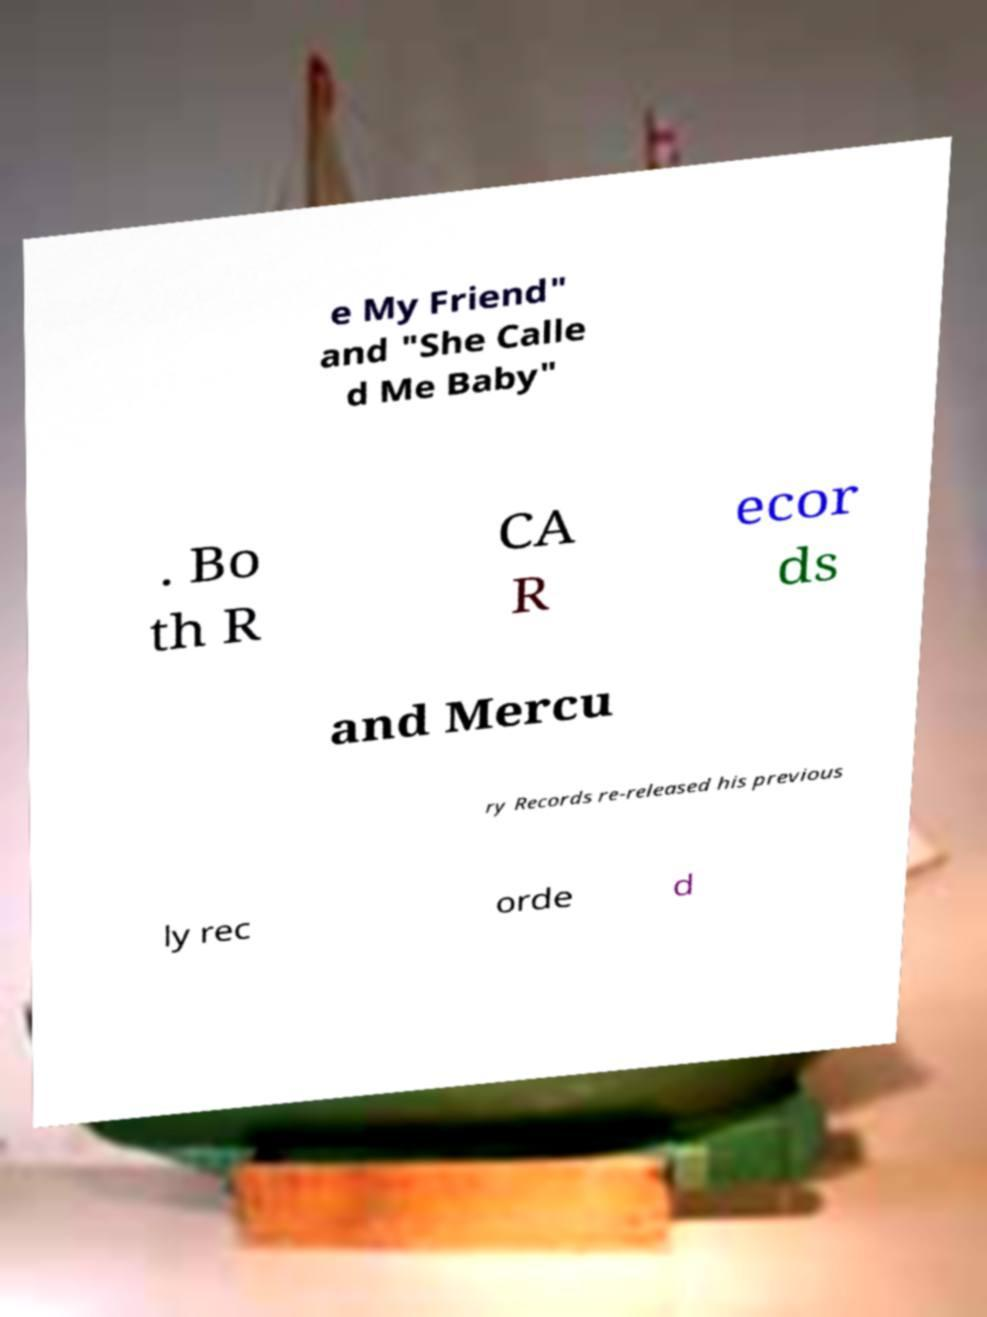Can you accurately transcribe the text from the provided image for me? e My Friend" and "She Calle d Me Baby" . Bo th R CA R ecor ds and Mercu ry Records re-released his previous ly rec orde d 